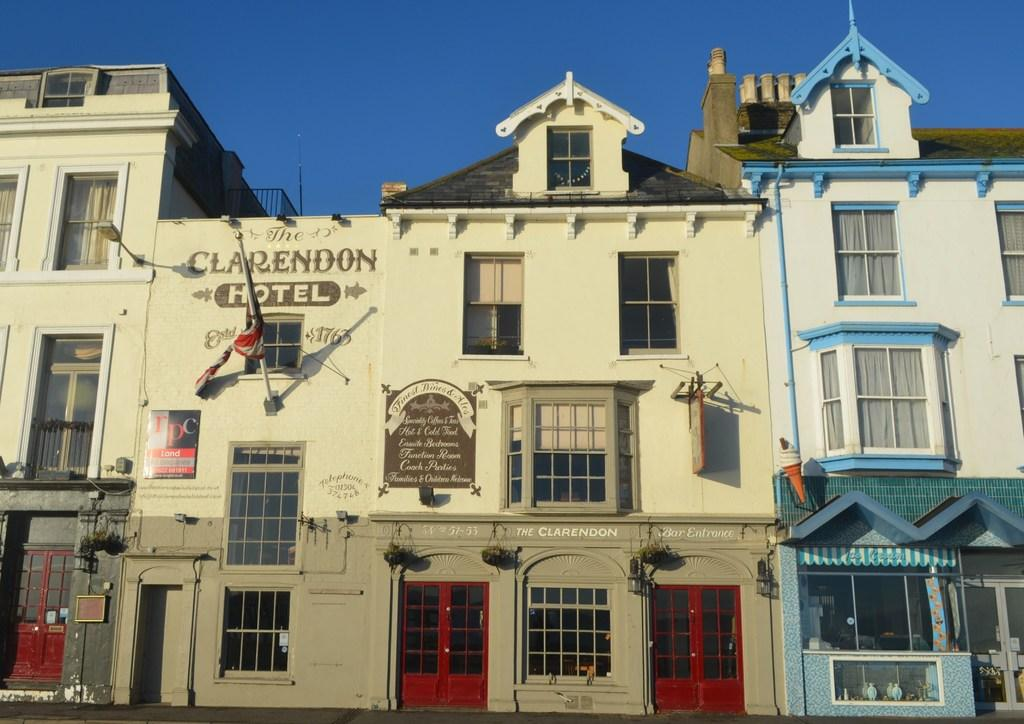What type of structure is present in the image? There is a building in the image. What colors can be seen on the building? The building has cream, white, and blue colors. What is the color of the doors on the building? The doors on the building are red. What else can be seen in the image besides the building? There is a stall in the image. What is visible in the background of the image? The sky is blue in the background of the image. How many feet are visible on the building in the image? There are no feet visible on the building in the image. What type of force is being applied to the building in the image? There is no indication of any force being applied to the building in the image. 